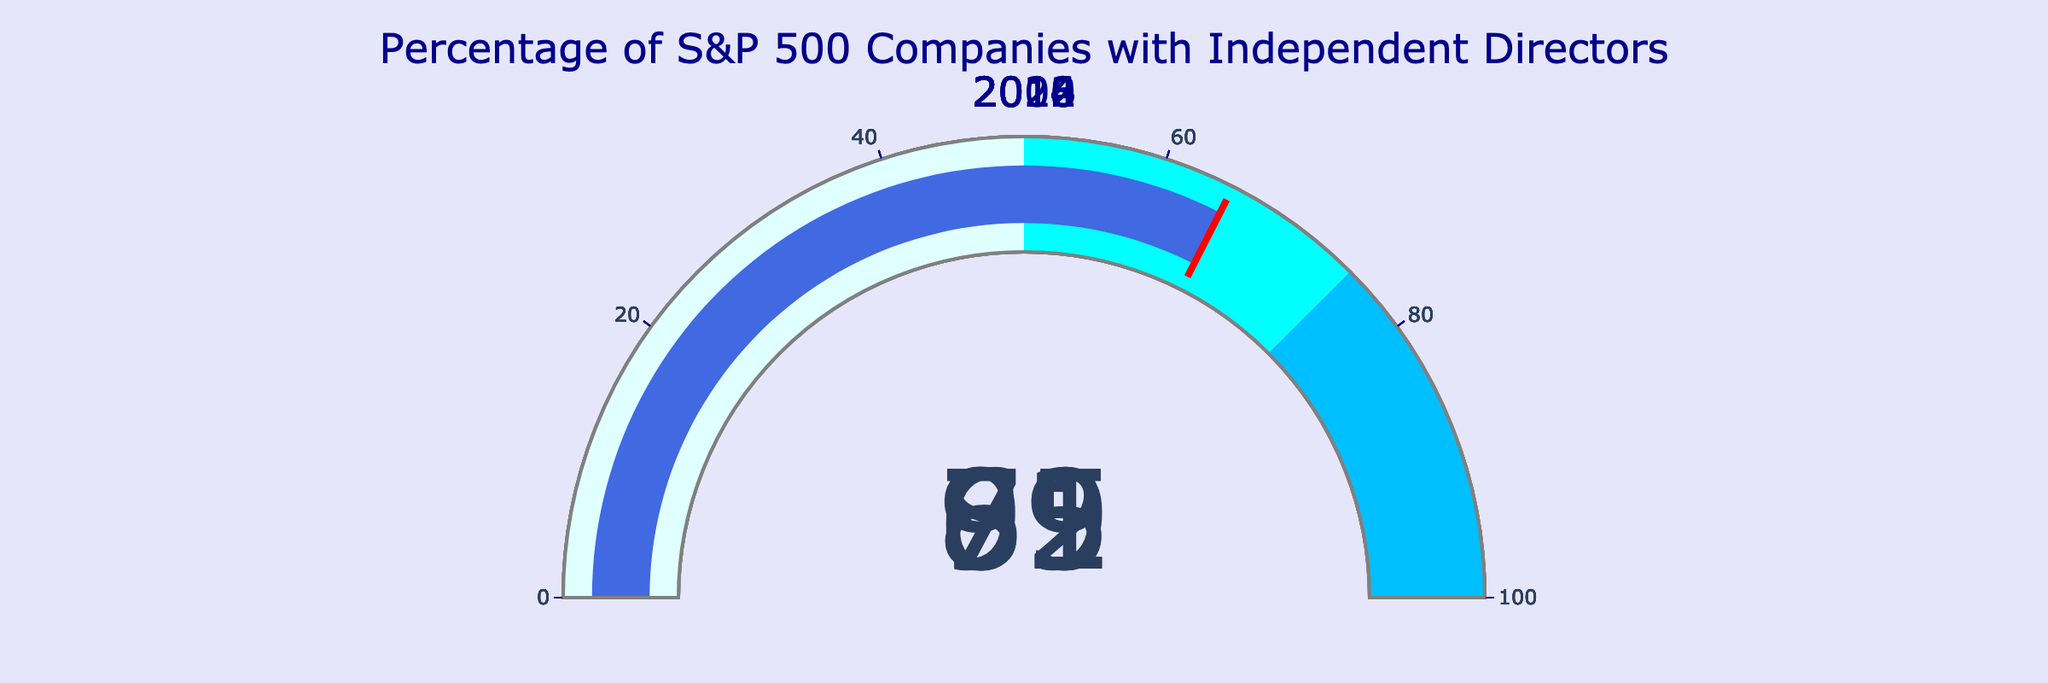What is the highest percentage of S&P 500 companies with independent directors? To find the highest percentage, look at the values shown on each gauge. The highest value can be identified visually.
Answer: 91% In what year was the lowest percentage of S&P 500 companies with independent directors recorded? Identify the year with the smallest value on the gauges from the visual representation.
Answer: 2006 What is the average percentage of S&P 500 companies with independent directors over the years displayed? Add all the percentages together and divide by the number of years: (65 + 72 + 79 + 85 + 91) / 5 = 78.4
Answer: 78.4 By how much did the percentage of S&P 500 companies with independent directors increase from 2006 to 2022? Subtract the percentage in 2006 from the percentage in 2022: 91 - 65 = 26
Answer: 26 Which year saw a percentage that is in the mid-70s? Identify the year on the gauge where the percentage is in the range of 74 to 76.
Answer: 2014 How many years displayed show a percentage of S&P 500 companies with independent directors greater than 80%? Count the number of years where the values on the gauges are above 80%.
Answer: 2 What is the sum of the percentages of S&P 500 companies with independent directors for the years 2010 and 2014? Add the percentages for the years 2010 and 2014: 72 + 79 = 151
Answer: 151 Did the percentage of S&P 500 companies with independent directors always increase over the years shown? Check each year sequentially to determine if every subsequent year has a higher percentage than the previous one.
Answer: Yes 